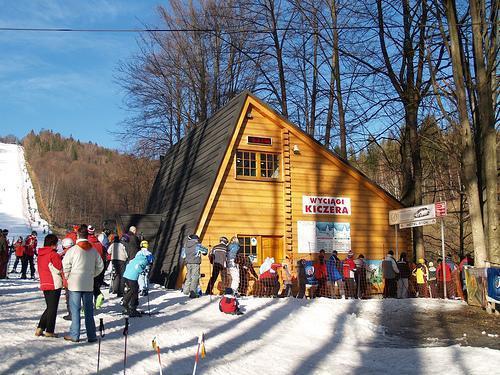How many people are visible?
Give a very brief answer. 3. 